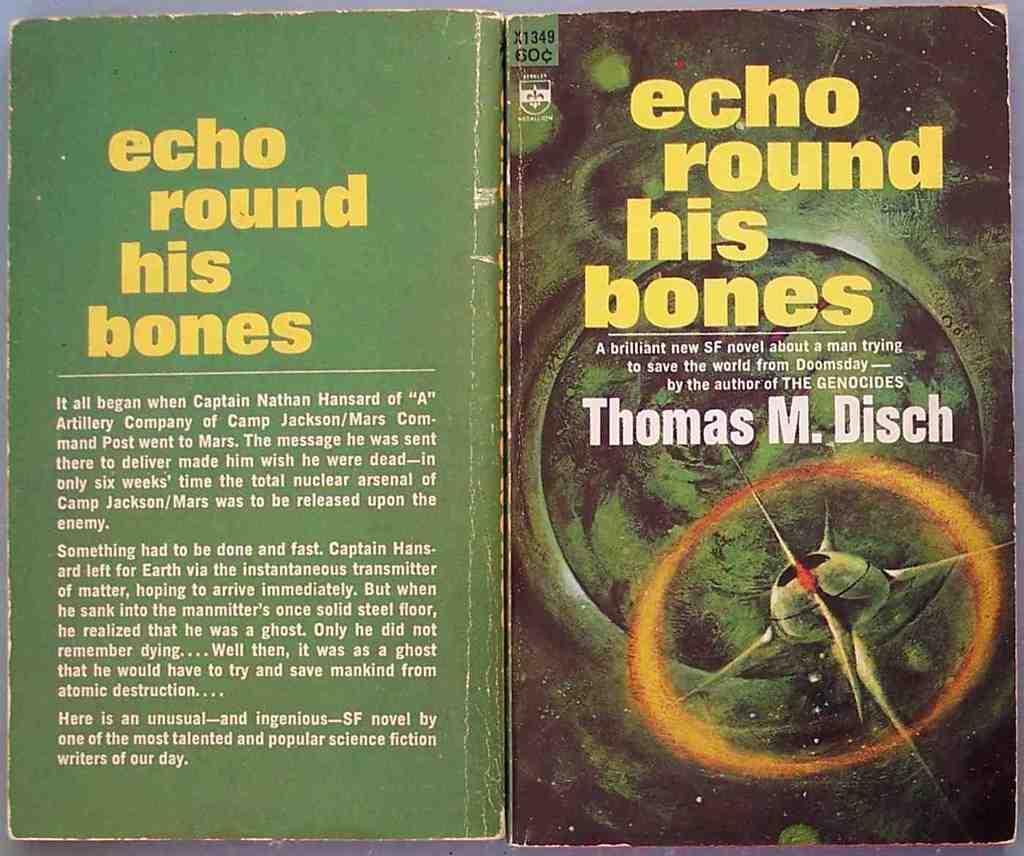What does the back say about this book?
Provide a succinct answer. Echo round his bones. Who is the author?
Your answer should be compact. Thomas m. disch. 